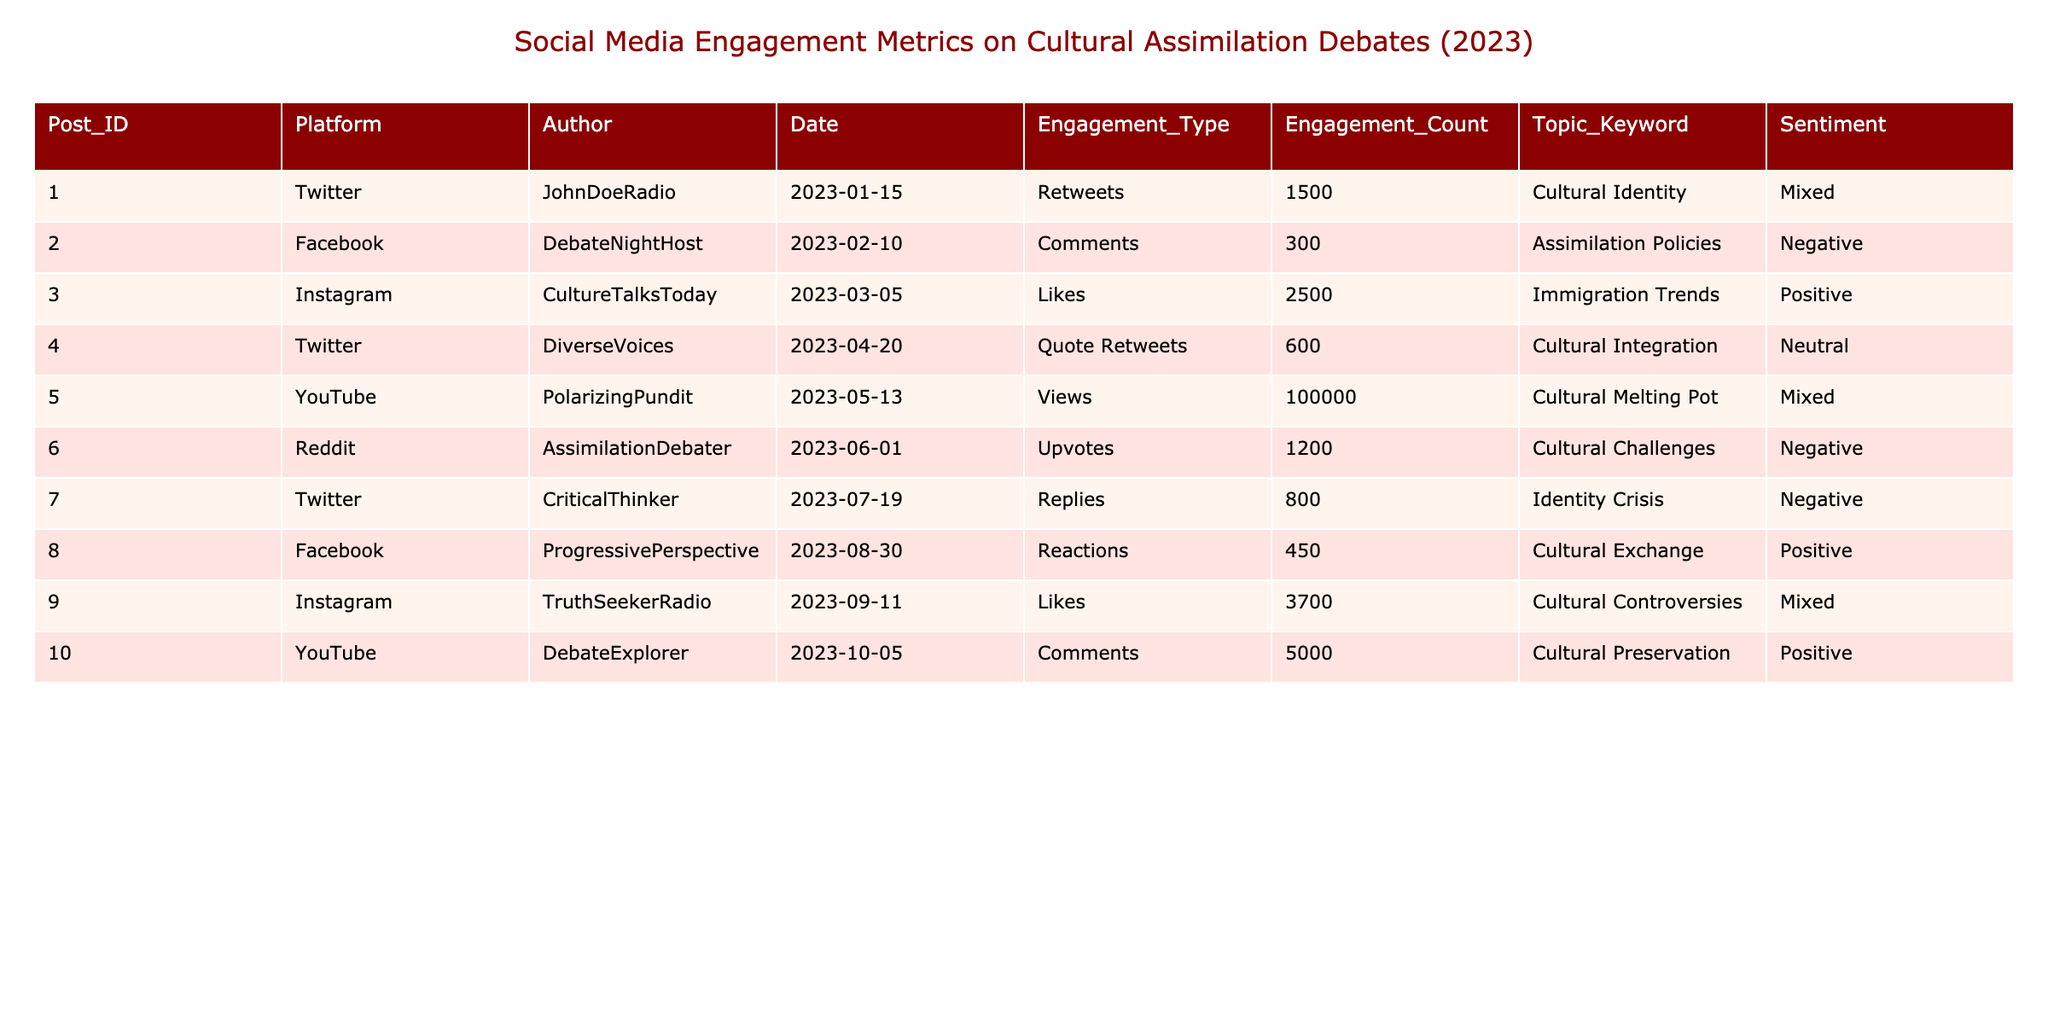What is the highest engagement count for a single post? The highest engagement count in the table is found in the YouTube post by PolarizingPundit, which has 100,000 views.
Answer: 100,000 Which platform had the most posts in the table? By counting the entries, Twitter has the most posts with 3 entries (Post IDs 1, 4, and 7).
Answer: Twitter What is the total engagement count for all posts related to "Cultural Entropy"? There are no posts related to "Cultural Entropy" in the table, so the total engagement count is 0.
Answer: 0 How many posts have a positive sentiment? There are 4 posts with a positive sentiment: Posts 3, 8, 9, and 10 out of the total 10 posts.
Answer: 4 What is the average engagement count for the posts categorized under "Cultural Identity"? The only post under "Cultural Identity" has an engagement count of 1500, so the average is just that value.
Answer: 1500 Which sentiment category had the least engagement count overall? The posts with negative sentiment (Posts 2, 6, and 7) have engagement counts of 300, 1200, and 800 respectively, summing to 2300, which is less than any other sentiment category total.
Answer: Negative How does the engagement count of posts with "Cultural Exchange" compare to "Cultural Preservation"? The engagement count for "Cultural Exchange" is 450 from Facebook, while "Cultural Preservation" has 5000 from YouTube. This shows that "Cultural Preservation" has significantly more engagement.
Answer: "Cultural Preservation" has more engagement What is the difference in engagement counts between the post with the most likes and the one with the most views? The post with the most likes (Post 9) has 3700 likes compared to the highest views (Post 5) which has 100,000. So the difference is 100,000 - 3700 = 96,300.
Answer: 96,300 On which date was the post with the highest engagement created? The post with the highest engagement count (Post 5) was created on May 13, 2023.
Answer: May 13, 2023 Is there a post with more comments than likes? Yes, the post by DebateNightHost on Facebook has 300 comments, while the post with the most likes (Post 9) has 3700 likes.
Answer: Yes 